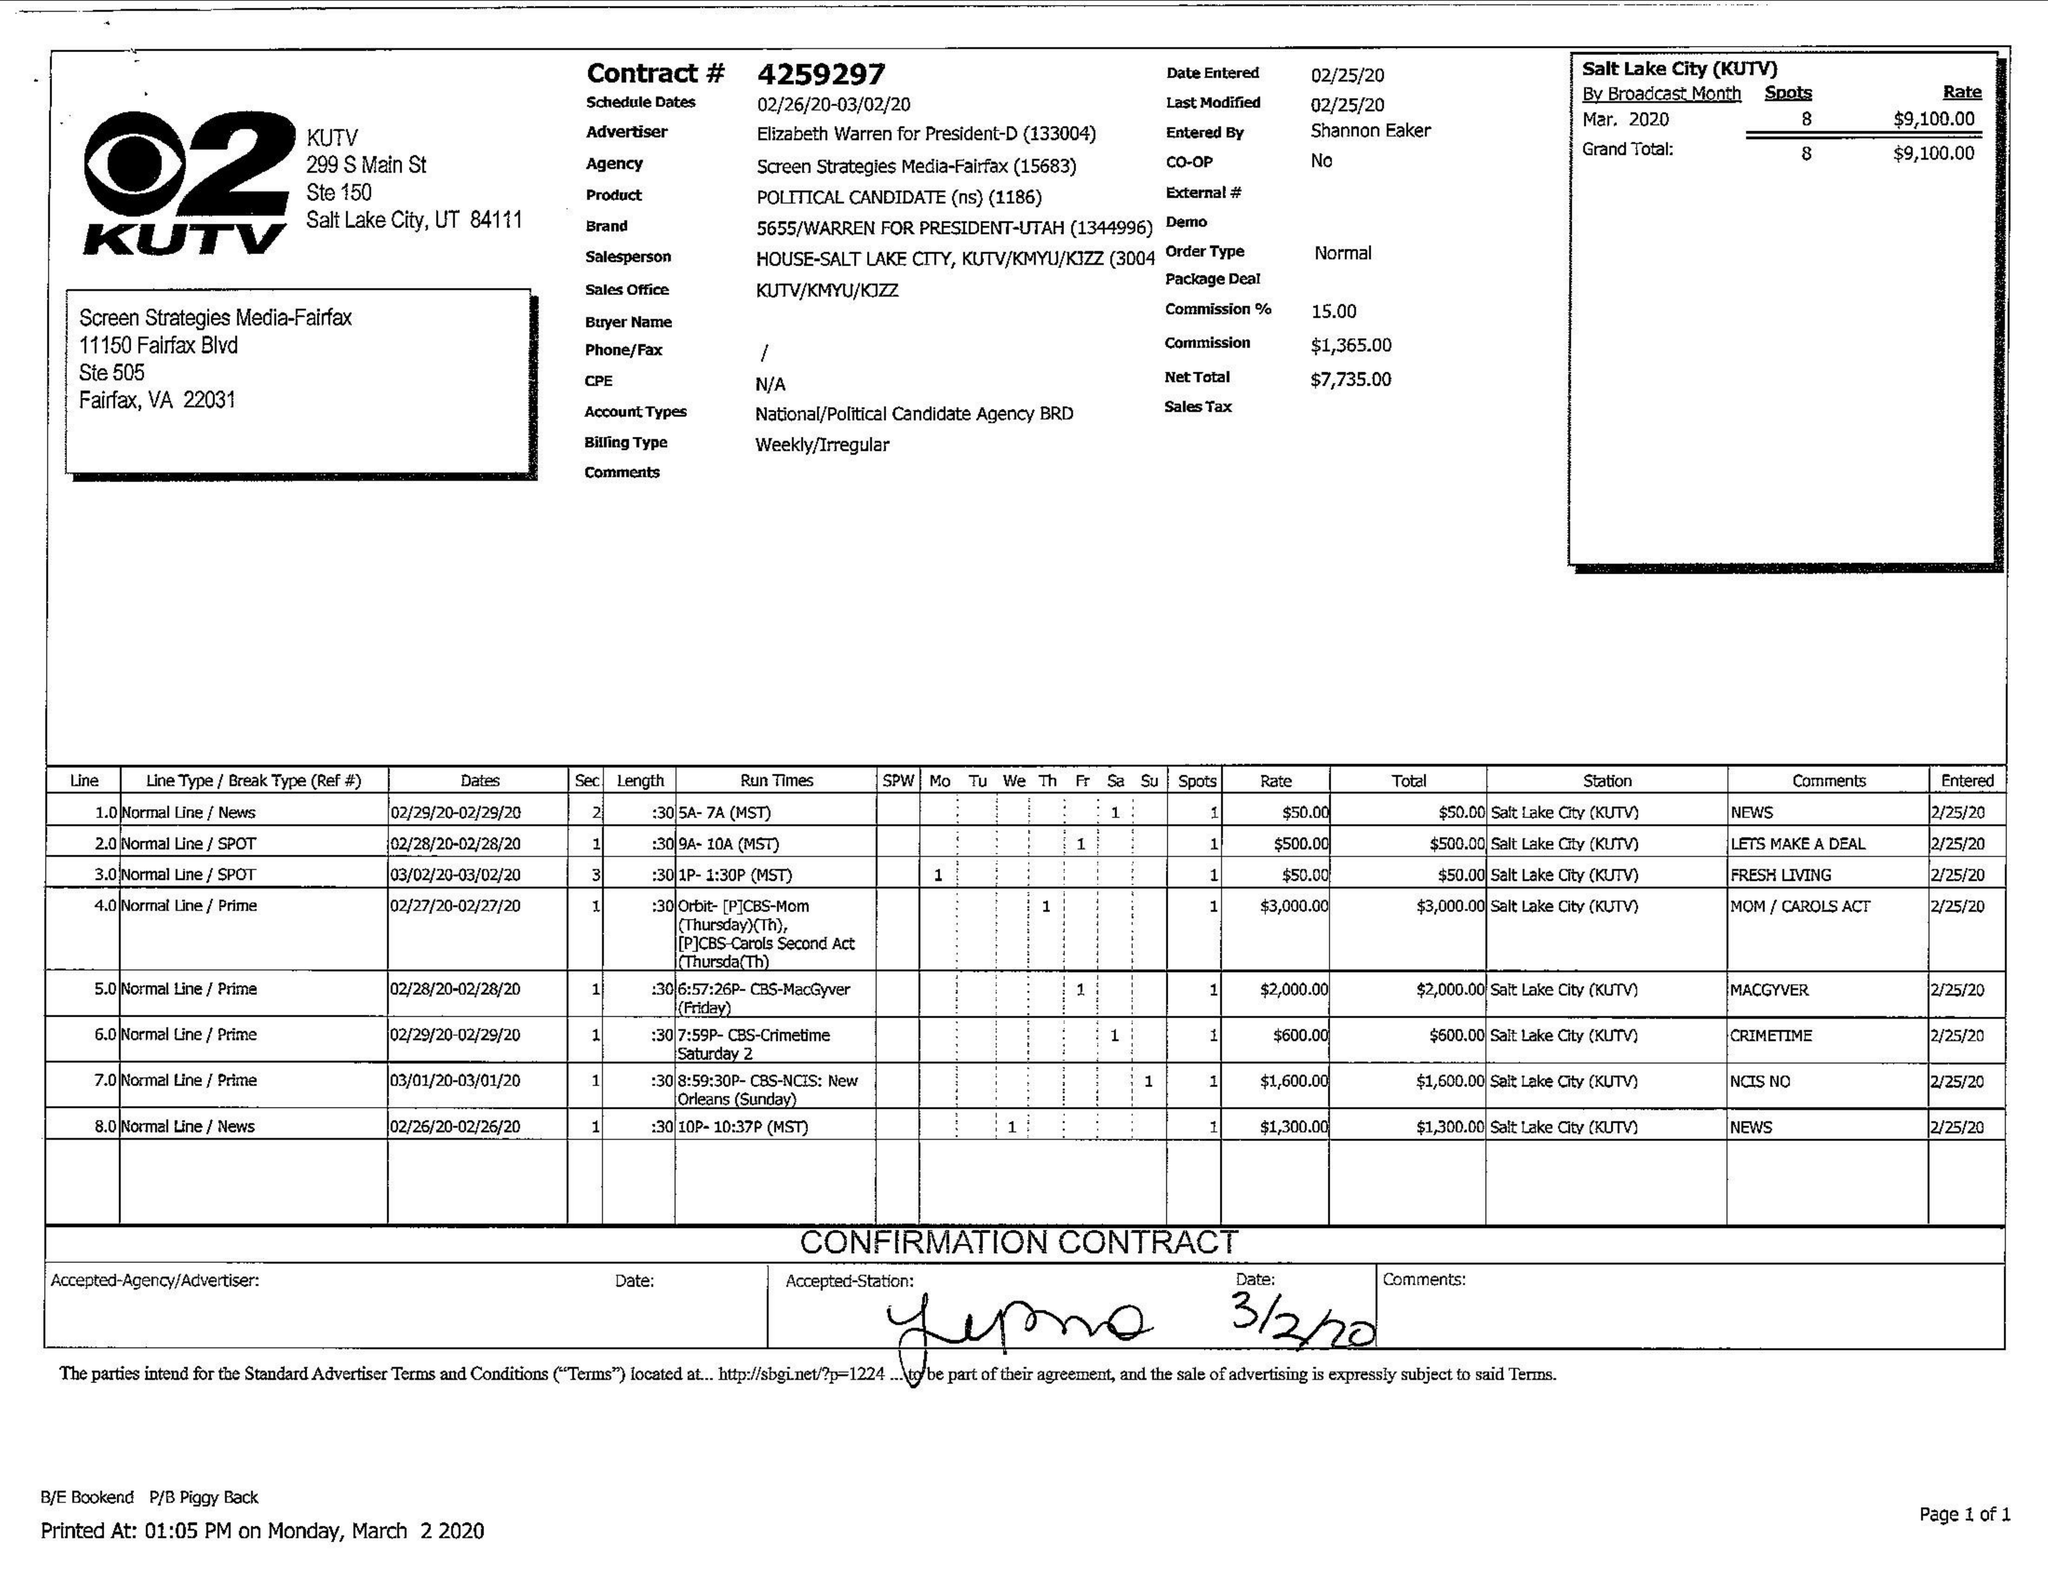What is the value for the flight_to?
Answer the question using a single word or phrase. 03/02/20 